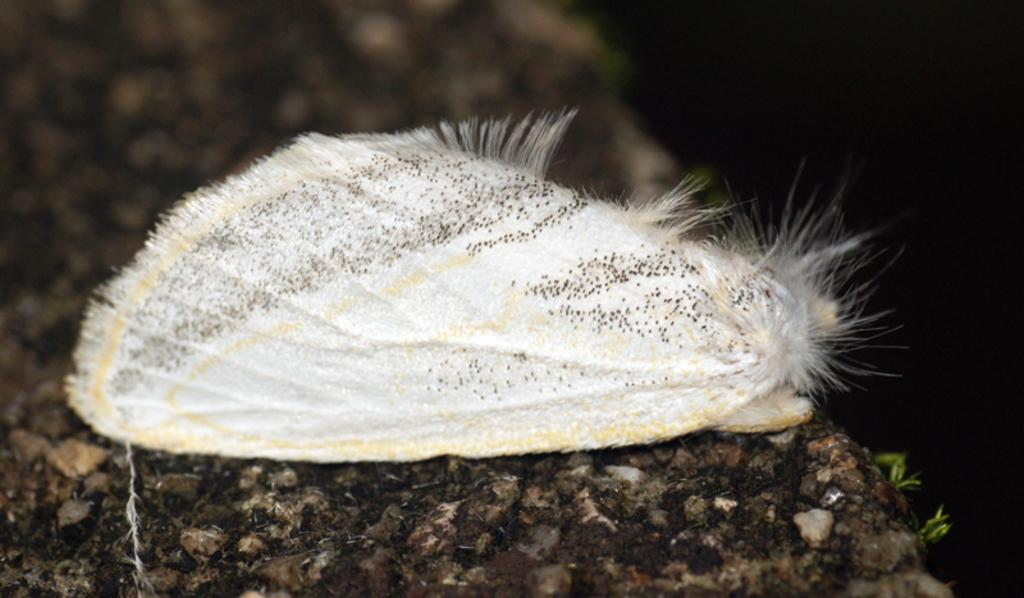What type of insect is on the stone in the image? There is a white moth on the stone in the image. What else can be seen in the image besides the moth? Plants are visible in the image. How many loaves of bread can be seen on the hill in the image? There is no hill or bread present in the image; it features a white moth on a stone and plants. 